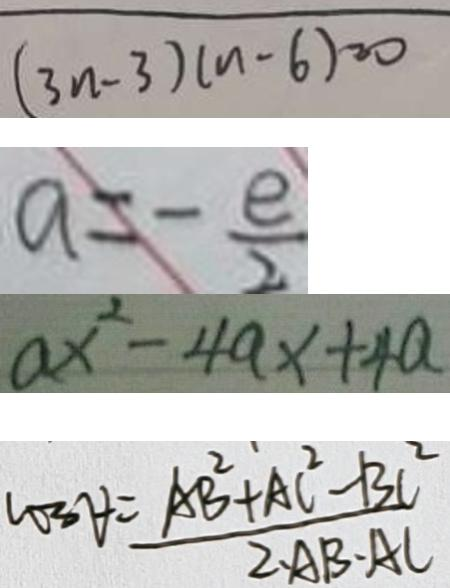Convert formula to latex. <formula><loc_0><loc_0><loc_500><loc_500>( 3 n - 3 ) ( n - 6 ) = 0 
 a = - \frac { e } { 2 } 
 a x ^ { 2 } - 4 a x + 4 a 
 c o 3 \forall = \frac { A B ^ { 2 } + A C ^ { 2 } - B C ^ { 2 } } { 2 \cdot A B \cdot A C }</formula> 